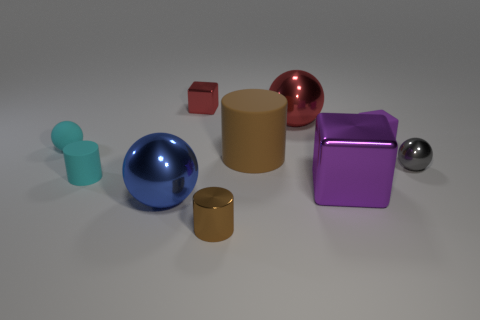What number of other objects are the same color as the big matte cylinder?
Keep it short and to the point. 1. The metal ball that is to the right of the brown matte thing and on the left side of the tiny purple rubber block is what color?
Provide a short and direct response. Red. What number of tiny things are there?
Give a very brief answer. 6. Do the big brown object and the red sphere have the same material?
Give a very brief answer. No. The tiny cyan thing in front of the brown cylinder behind the small ball that is on the right side of the large red sphere is what shape?
Give a very brief answer. Cylinder. Is the small cylinder in front of the blue sphere made of the same material as the red object that is on the left side of the big red thing?
Offer a very short reply. Yes. What is the cyan cylinder made of?
Offer a very short reply. Rubber. How many blue metallic objects have the same shape as the small purple object?
Provide a short and direct response. 0. There is another cube that is the same color as the big block; what is its material?
Your answer should be very brief. Rubber. Are there any other things that have the same shape as the tiny brown thing?
Provide a succinct answer. Yes. 